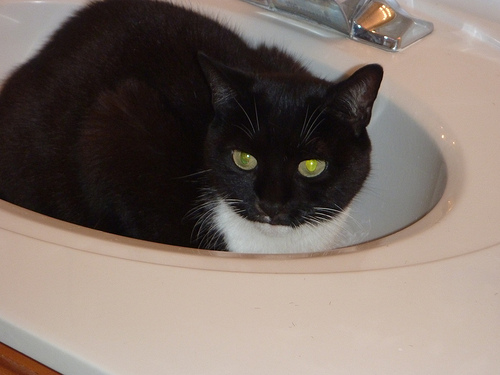Aside from the cat, what details can you tell me about the space? The bathroom appears simplistic, with a counter surrounding the sink. No personal items or toiletries are visible, suggesting the space is either meticulously maintained or not frequently used. The color palette is neutral, with light tones prevailing. 